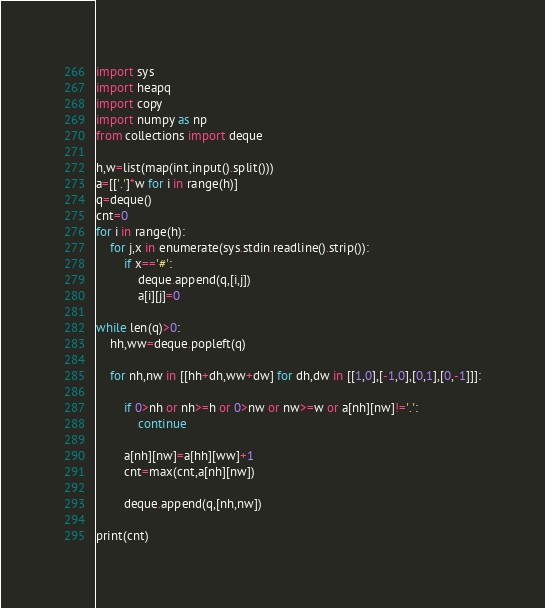Convert code to text. <code><loc_0><loc_0><loc_500><loc_500><_Python_>import sys
import heapq
import copy
import numpy as np
from collections import deque

h,w=list(map(int,input().split()))
a=[['.']*w for i in range(h)]
q=deque()
cnt=0
for i in range(h):
    for j,x in enumerate(sys.stdin.readline().strip()):
        if x=='#':
            deque.append(q,[i,j])
            a[i][j]=0

while len(q)>0:
    hh,ww=deque.popleft(q)

    for nh,nw in [[hh+dh,ww+dw] for dh,dw in [[1,0],[-1,0],[0,1],[0,-1]]]:
        
        if 0>nh or nh>=h or 0>nw or nw>=w or a[nh][nw]!='.':
            continue
        
        a[nh][nw]=a[hh][ww]+1
        cnt=max(cnt,a[nh][nw])

        deque.append(q,[nh,nw])

print(cnt)
</code> 